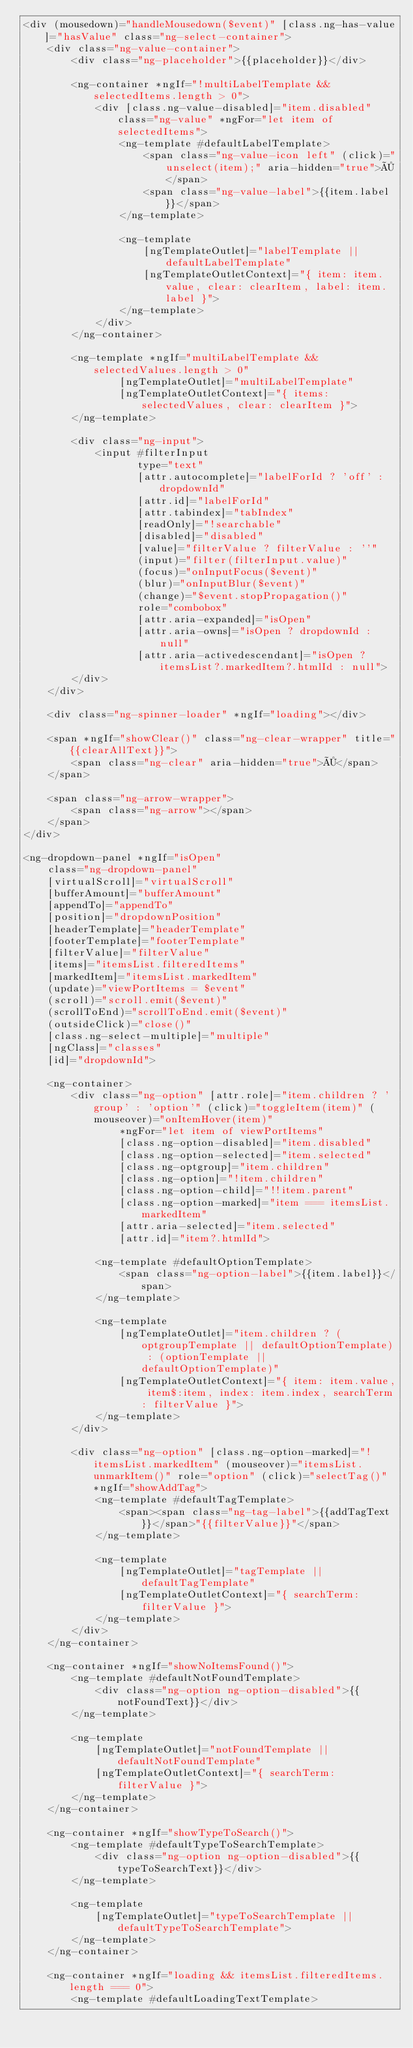Convert code to text. <code><loc_0><loc_0><loc_500><loc_500><_HTML_><div (mousedown)="handleMousedown($event)" [class.ng-has-value]="hasValue" class="ng-select-container">
    <div class="ng-value-container">
        <div class="ng-placeholder">{{placeholder}}</div>

        <ng-container *ngIf="!multiLabelTemplate && selectedItems.length > 0">
            <div [class.ng-value-disabled]="item.disabled" class="ng-value" *ngFor="let item of selectedItems">
                <ng-template #defaultLabelTemplate>
                    <span class="ng-value-icon left" (click)="unselect(item);" aria-hidden="true">×</span>
                    <span class="ng-value-label">{{item.label}}</span>
                </ng-template>

                <ng-template
                    [ngTemplateOutlet]="labelTemplate || defaultLabelTemplate"
                    [ngTemplateOutletContext]="{ item: item.value, clear: clearItem, label: item.label }">
                </ng-template>
            </div>
        </ng-container>

        <ng-template *ngIf="multiLabelTemplate && selectedValues.length > 0"
                [ngTemplateOutlet]="multiLabelTemplate"
                [ngTemplateOutletContext]="{ items: selectedValues, clear: clearItem }">
        </ng-template>

        <div class="ng-input">
            <input #filterInput
                   type="text"
                   [attr.autocomplete]="labelForId ? 'off' : dropdownId"
                   [attr.id]="labelForId"
                   [attr.tabindex]="tabIndex"
                   [readOnly]="!searchable"
                   [disabled]="disabled"
                   [value]="filterValue ? filterValue : ''"
                   (input)="filter(filterInput.value)"
                   (focus)="onInputFocus($event)"
                   (blur)="onInputBlur($event)"
                   (change)="$event.stopPropagation()"
                   role="combobox"
                   [attr.aria-expanded]="isOpen"
                   [attr.aria-owns]="isOpen ? dropdownId : null"
                   [attr.aria-activedescendant]="isOpen ? itemsList?.markedItem?.htmlId : null">
        </div>
    </div>

    <div class="ng-spinner-loader" *ngIf="loading"></div>

    <span *ngIf="showClear()" class="ng-clear-wrapper" title="{{clearAllText}}">
        <span class="ng-clear" aria-hidden="true">×</span>
    </span>

    <span class="ng-arrow-wrapper">
        <span class="ng-arrow"></span>
    </span>
</div>

<ng-dropdown-panel *ngIf="isOpen"
    class="ng-dropdown-panel"
    [virtualScroll]="virtualScroll"
    [bufferAmount]="bufferAmount"
    [appendTo]="appendTo"
    [position]="dropdownPosition"
    [headerTemplate]="headerTemplate"
    [footerTemplate]="footerTemplate"
    [filterValue]="filterValue"
    [items]="itemsList.filteredItems"
    [markedItem]="itemsList.markedItem"
    (update)="viewPortItems = $event"
    (scroll)="scroll.emit($event)"
    (scrollToEnd)="scrollToEnd.emit($event)"
    (outsideClick)="close()"
    [class.ng-select-multiple]="multiple"
    [ngClass]="classes"
    [id]="dropdownId">

    <ng-container>
        <div class="ng-option" [attr.role]="item.children ? 'group' : 'option'" (click)="toggleItem(item)" (mouseover)="onItemHover(item)"
                *ngFor="let item of viewPortItems"
                [class.ng-option-disabled]="item.disabled"
                [class.ng-option-selected]="item.selected"
                [class.ng-optgroup]="item.children"
                [class.ng-option]="!item.children"
                [class.ng-option-child]="!!item.parent"
                [class.ng-option-marked]="item === itemsList.markedItem"
                [attr.aria-selected]="item.selected"
                [attr.id]="item?.htmlId">

            <ng-template #defaultOptionTemplate>
                <span class="ng-option-label">{{item.label}}</span>
            </ng-template>

            <ng-template
                [ngTemplateOutlet]="item.children ? (optgroupTemplate || defaultOptionTemplate) : (optionTemplate || defaultOptionTemplate)"
                [ngTemplateOutletContext]="{ item: item.value, item$:item, index: item.index, searchTerm: filterValue }">
            </ng-template>
        </div>

        <div class="ng-option" [class.ng-option-marked]="!itemsList.markedItem" (mouseover)="itemsList.unmarkItem()" role="option" (click)="selectTag()" *ngIf="showAddTag">
            <ng-template #defaultTagTemplate>
                <span><span class="ng-tag-label">{{addTagText}}</span>"{{filterValue}}"</span>
            </ng-template>

            <ng-template
                [ngTemplateOutlet]="tagTemplate || defaultTagTemplate"
                [ngTemplateOutletContext]="{ searchTerm: filterValue }">
            </ng-template>
        </div>
    </ng-container>

    <ng-container *ngIf="showNoItemsFound()">
        <ng-template #defaultNotFoundTemplate>
            <div class="ng-option ng-option-disabled">{{notFoundText}}</div>
        </ng-template>

        <ng-template
            [ngTemplateOutlet]="notFoundTemplate || defaultNotFoundTemplate"
            [ngTemplateOutletContext]="{ searchTerm: filterValue }">
        </ng-template>
    </ng-container>

    <ng-container *ngIf="showTypeToSearch()">
        <ng-template #defaultTypeToSearchTemplate>
            <div class="ng-option ng-option-disabled">{{typeToSearchText}}</div>
        </ng-template>

        <ng-template
            [ngTemplateOutlet]="typeToSearchTemplate || defaultTypeToSearchTemplate">
        </ng-template>
    </ng-container>

    <ng-container *ngIf="loading && itemsList.filteredItems.length === 0">
        <ng-template #defaultLoadingTextTemplate></code> 